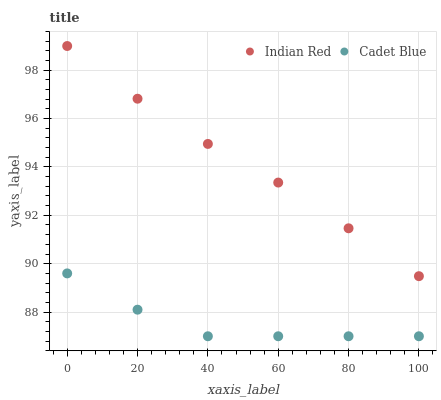Does Cadet Blue have the minimum area under the curve?
Answer yes or no. Yes. Does Indian Red have the maximum area under the curve?
Answer yes or no. Yes. Does Indian Red have the minimum area under the curve?
Answer yes or no. No. Is Indian Red the smoothest?
Answer yes or no. Yes. Is Cadet Blue the roughest?
Answer yes or no. Yes. Is Indian Red the roughest?
Answer yes or no. No. Does Cadet Blue have the lowest value?
Answer yes or no. Yes. Does Indian Red have the lowest value?
Answer yes or no. No. Does Indian Red have the highest value?
Answer yes or no. Yes. Is Cadet Blue less than Indian Red?
Answer yes or no. Yes. Is Indian Red greater than Cadet Blue?
Answer yes or no. Yes. Does Cadet Blue intersect Indian Red?
Answer yes or no. No. 